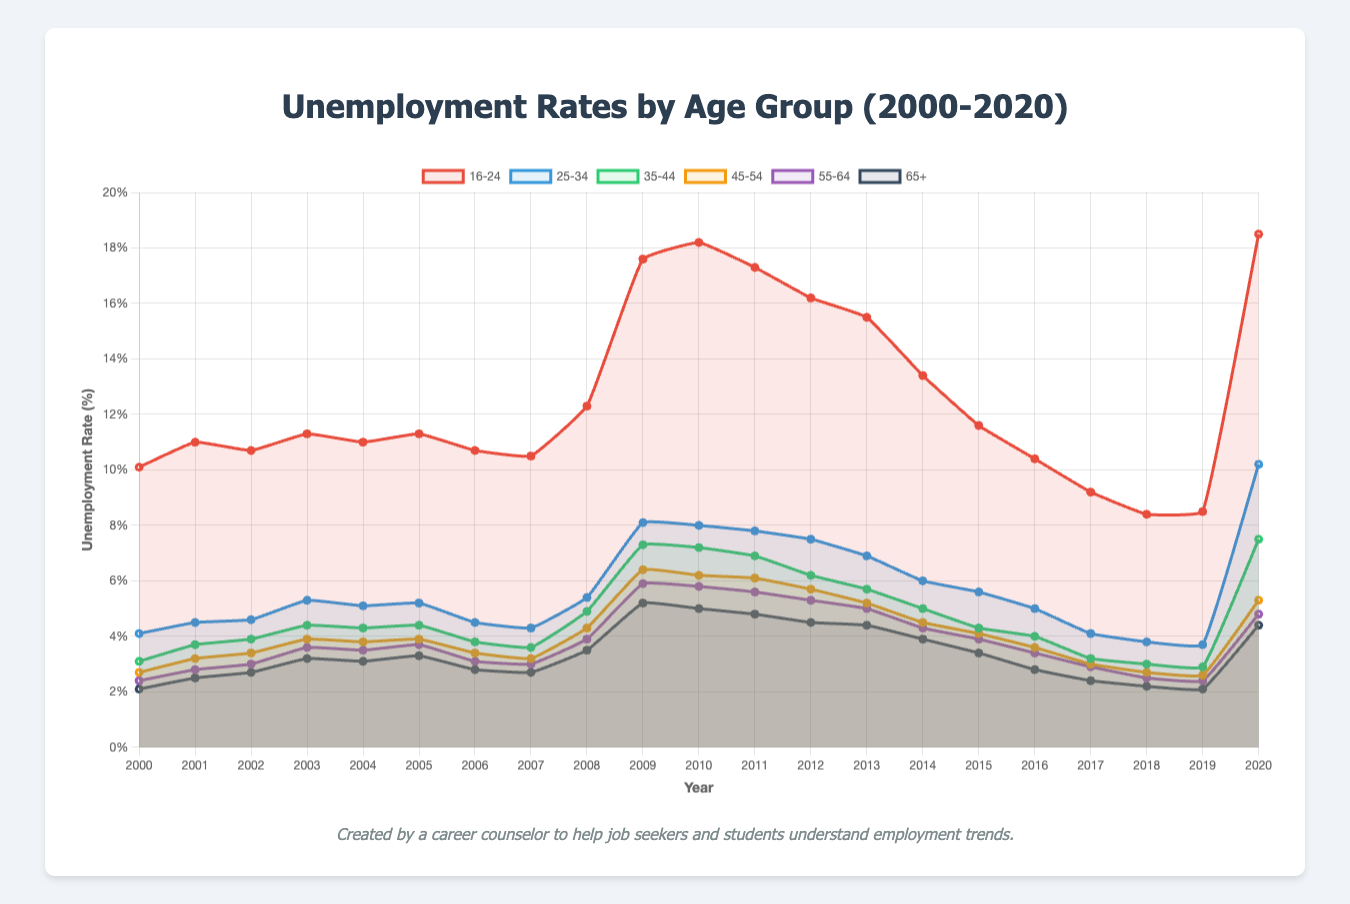What was the unemployment rate for the 16-24 age group in 2020? Refer to the figure and locate the data point for 2020 on the line corresponding to the 16-24 age group, which is marked in red.
Answer: 18.5% Which age group had the highest unemployment rate in 2010? Look at the data points for all age groups in 2010 and identify the one with the highest value. The 16-24 age group, shown in red, had the highest rate.
Answer: 16-24 How did the unemployment rate for the 35-44 age group in 2006 compare with that in 2017? Find the data points for the 35-44 age group in 2006 and 2017. The rate was 3.8% in 2006 and 3.2% in 2017. Compare the two values.
Answer: It decreased Which two age groups had nearly equal unemployment rates in 2007? Locate the data points for 2007 and compare the values of the unemployment rates. The 25-34 and 45-54 age groups had very close values of 4.3% and 3.2%, respectively.
Answer: 25-34, 45-54 Summarize the trend of unemployment rates for the 65+ age group from 2000 to 2020. Look at the data trend for the 65+ age group. The unemployment rate starts at 2.1% in 2000, peaks at 5.2% in 2009, and declines to 4.4% by 2020. Describe this overall trend.
Answer: Increased and then slightly decreased What is the difference in the unemployment rates between 2003 and 2010 for the 55-64 age group? Find the values for 2003 and 2010 for the 55-64 age group. The values are 3.6% and 5.9%, respectively. Subtract 3.6% from 5.9% to get the difference.
Answer: 2.3% In which year did the 25-34 age group experience the sharpest increase in unemployment rate? Identify changes in the unemployment rates for 25-34. The sharpest increase is from 5.4% in 2008 to 8.1% in 2009.
Answer: 2009 Compare the overall trend of unemployment rates from 2000 to 2020 for the age groups 16-24 and 55-64. Observe the trends for both age groups. The 16-24 age group shows a highly fluctuating trend with a significant peak in 2009, while the 55-64 age group exhibits a more stable trend with smaller fluctuations.
Answer: 16-24 is more volatile Which age group had the most stable unemployment rate from 2000 to 2020? Look at the fluctuations of the lines representing different age groups. The 65+ age group shows the least volatility in its unemployment rate over time.
Answer: 65+ 